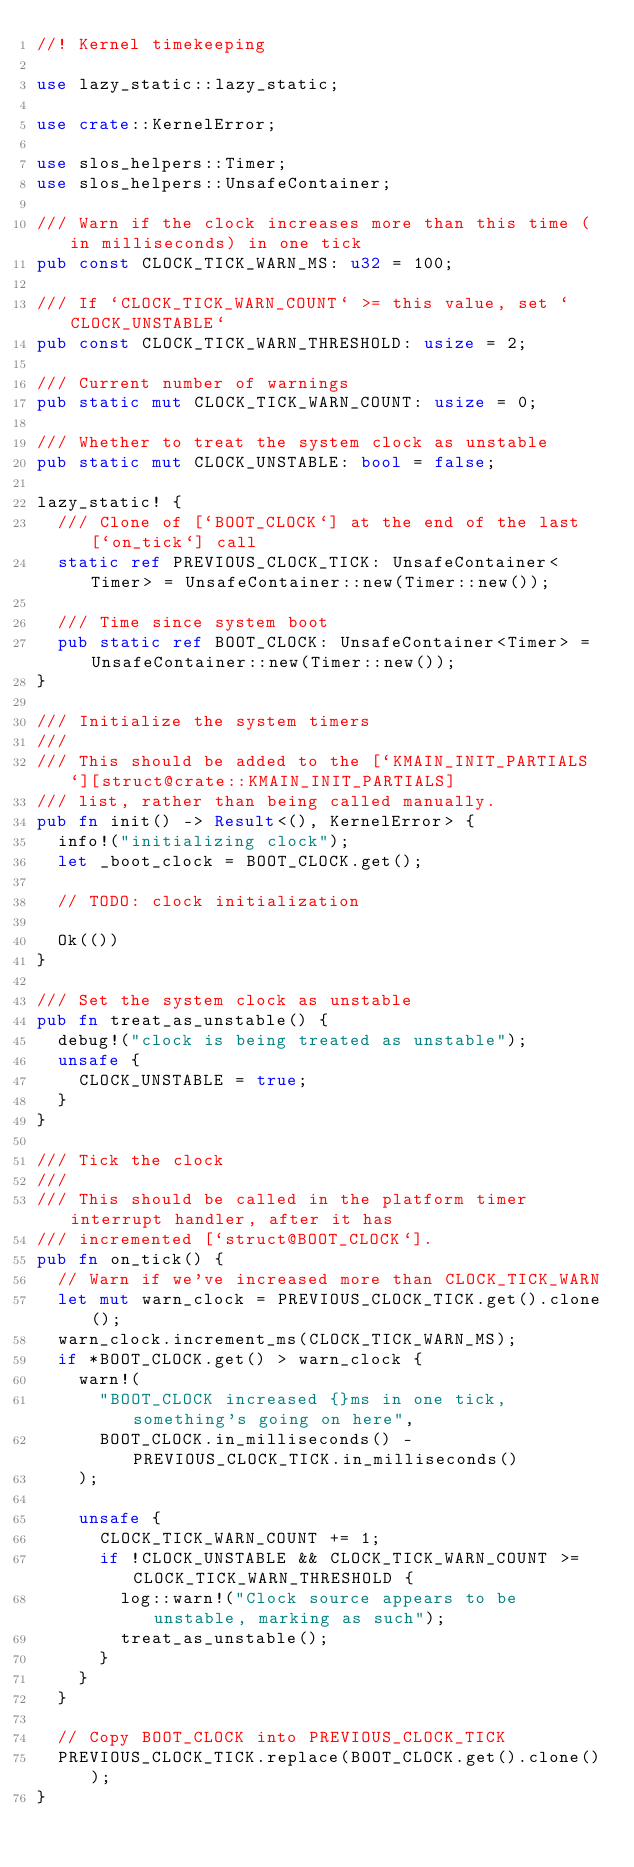Convert code to text. <code><loc_0><loc_0><loc_500><loc_500><_Rust_>//! Kernel timekeeping

use lazy_static::lazy_static;

use crate::KernelError;

use slos_helpers::Timer;
use slos_helpers::UnsafeContainer;

/// Warn if the clock increases more than this time (in milliseconds) in one tick
pub const CLOCK_TICK_WARN_MS: u32 = 100;

/// If `CLOCK_TICK_WARN_COUNT` >= this value, set `CLOCK_UNSTABLE`
pub const CLOCK_TICK_WARN_THRESHOLD: usize = 2;

/// Current number of warnings
pub static mut CLOCK_TICK_WARN_COUNT: usize = 0;

/// Whether to treat the system clock as unstable
pub static mut CLOCK_UNSTABLE: bool = false;

lazy_static! {
	/// Clone of [`BOOT_CLOCK`] at the end of the last [`on_tick`] call
	static ref PREVIOUS_CLOCK_TICK: UnsafeContainer<Timer> = UnsafeContainer::new(Timer::new());

	/// Time since system boot
	pub static ref BOOT_CLOCK: UnsafeContainer<Timer> = UnsafeContainer::new(Timer::new());
}

/// Initialize the system timers
///
/// This should be added to the [`KMAIN_INIT_PARTIALS`][struct@crate::KMAIN_INIT_PARTIALS]
/// list, rather than being called manually.
pub fn init() -> Result<(), KernelError> {
	info!("initializing clock");
	let _boot_clock = BOOT_CLOCK.get();

	// TODO: clock initialization

	Ok(())
}

/// Set the system clock as unstable
pub fn treat_as_unstable() {
	debug!("clock is being treated as unstable");
	unsafe {
		CLOCK_UNSTABLE = true;
	}
}

/// Tick the clock
///
/// This should be called in the platform timer interrupt handler, after it has
/// incremented [`struct@BOOT_CLOCK`].
pub fn on_tick() {
	// Warn if we've increased more than CLOCK_TICK_WARN
	let mut warn_clock = PREVIOUS_CLOCK_TICK.get().clone();
	warn_clock.increment_ms(CLOCK_TICK_WARN_MS);
	if *BOOT_CLOCK.get() > warn_clock {
		warn!(
			"BOOT_CLOCK increased {}ms in one tick, something's going on here",
			BOOT_CLOCK.in_milliseconds() - PREVIOUS_CLOCK_TICK.in_milliseconds()
		);

		unsafe {
			CLOCK_TICK_WARN_COUNT += 1;
			if !CLOCK_UNSTABLE && CLOCK_TICK_WARN_COUNT >= CLOCK_TICK_WARN_THRESHOLD {
				log::warn!("Clock source appears to be unstable, marking as such");
				treat_as_unstable();
			}
		}
	}

	// Copy BOOT_CLOCK into PREVIOUS_CLOCK_TICK
	PREVIOUS_CLOCK_TICK.replace(BOOT_CLOCK.get().clone());
}
</code> 